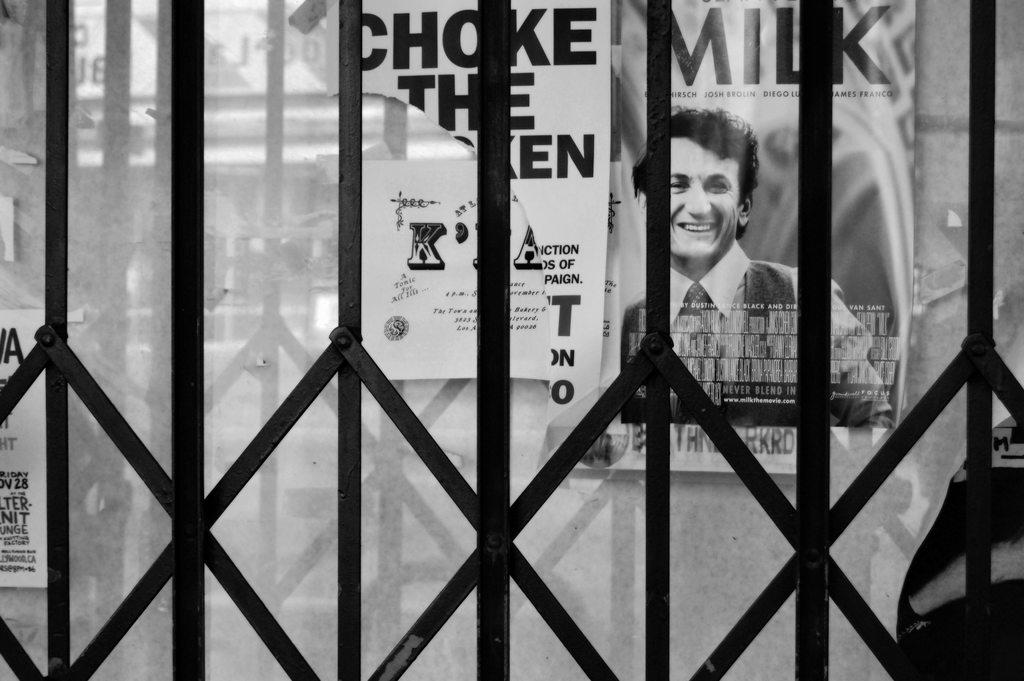What is the main object in the image? There is a grill in the image. What can be seen in the background of the image? There are posters in the background of the image. What type of fear can be seen on the writer's face in the image? There is no writer or fear present in the image; it only features a grill and posters in the background. 